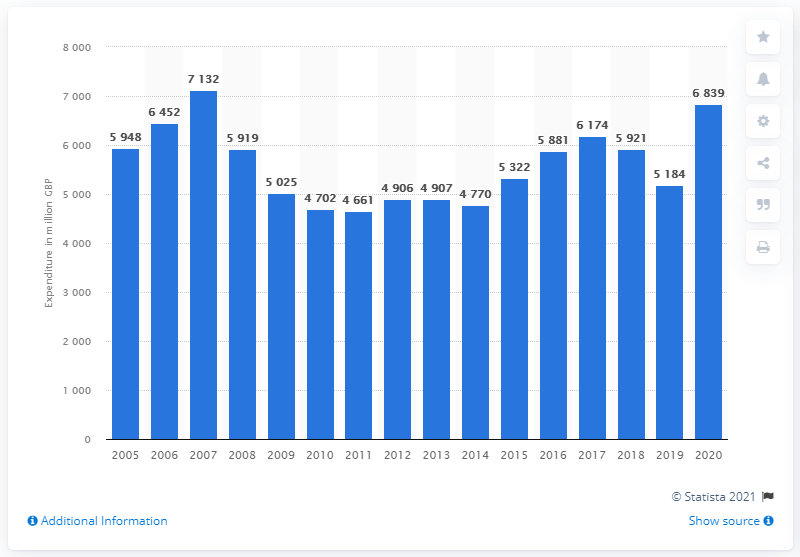Give some essential details in this illustration. In 2020, households in the UK purchased a total of 6,839 pounds worth of tools and equipment. 